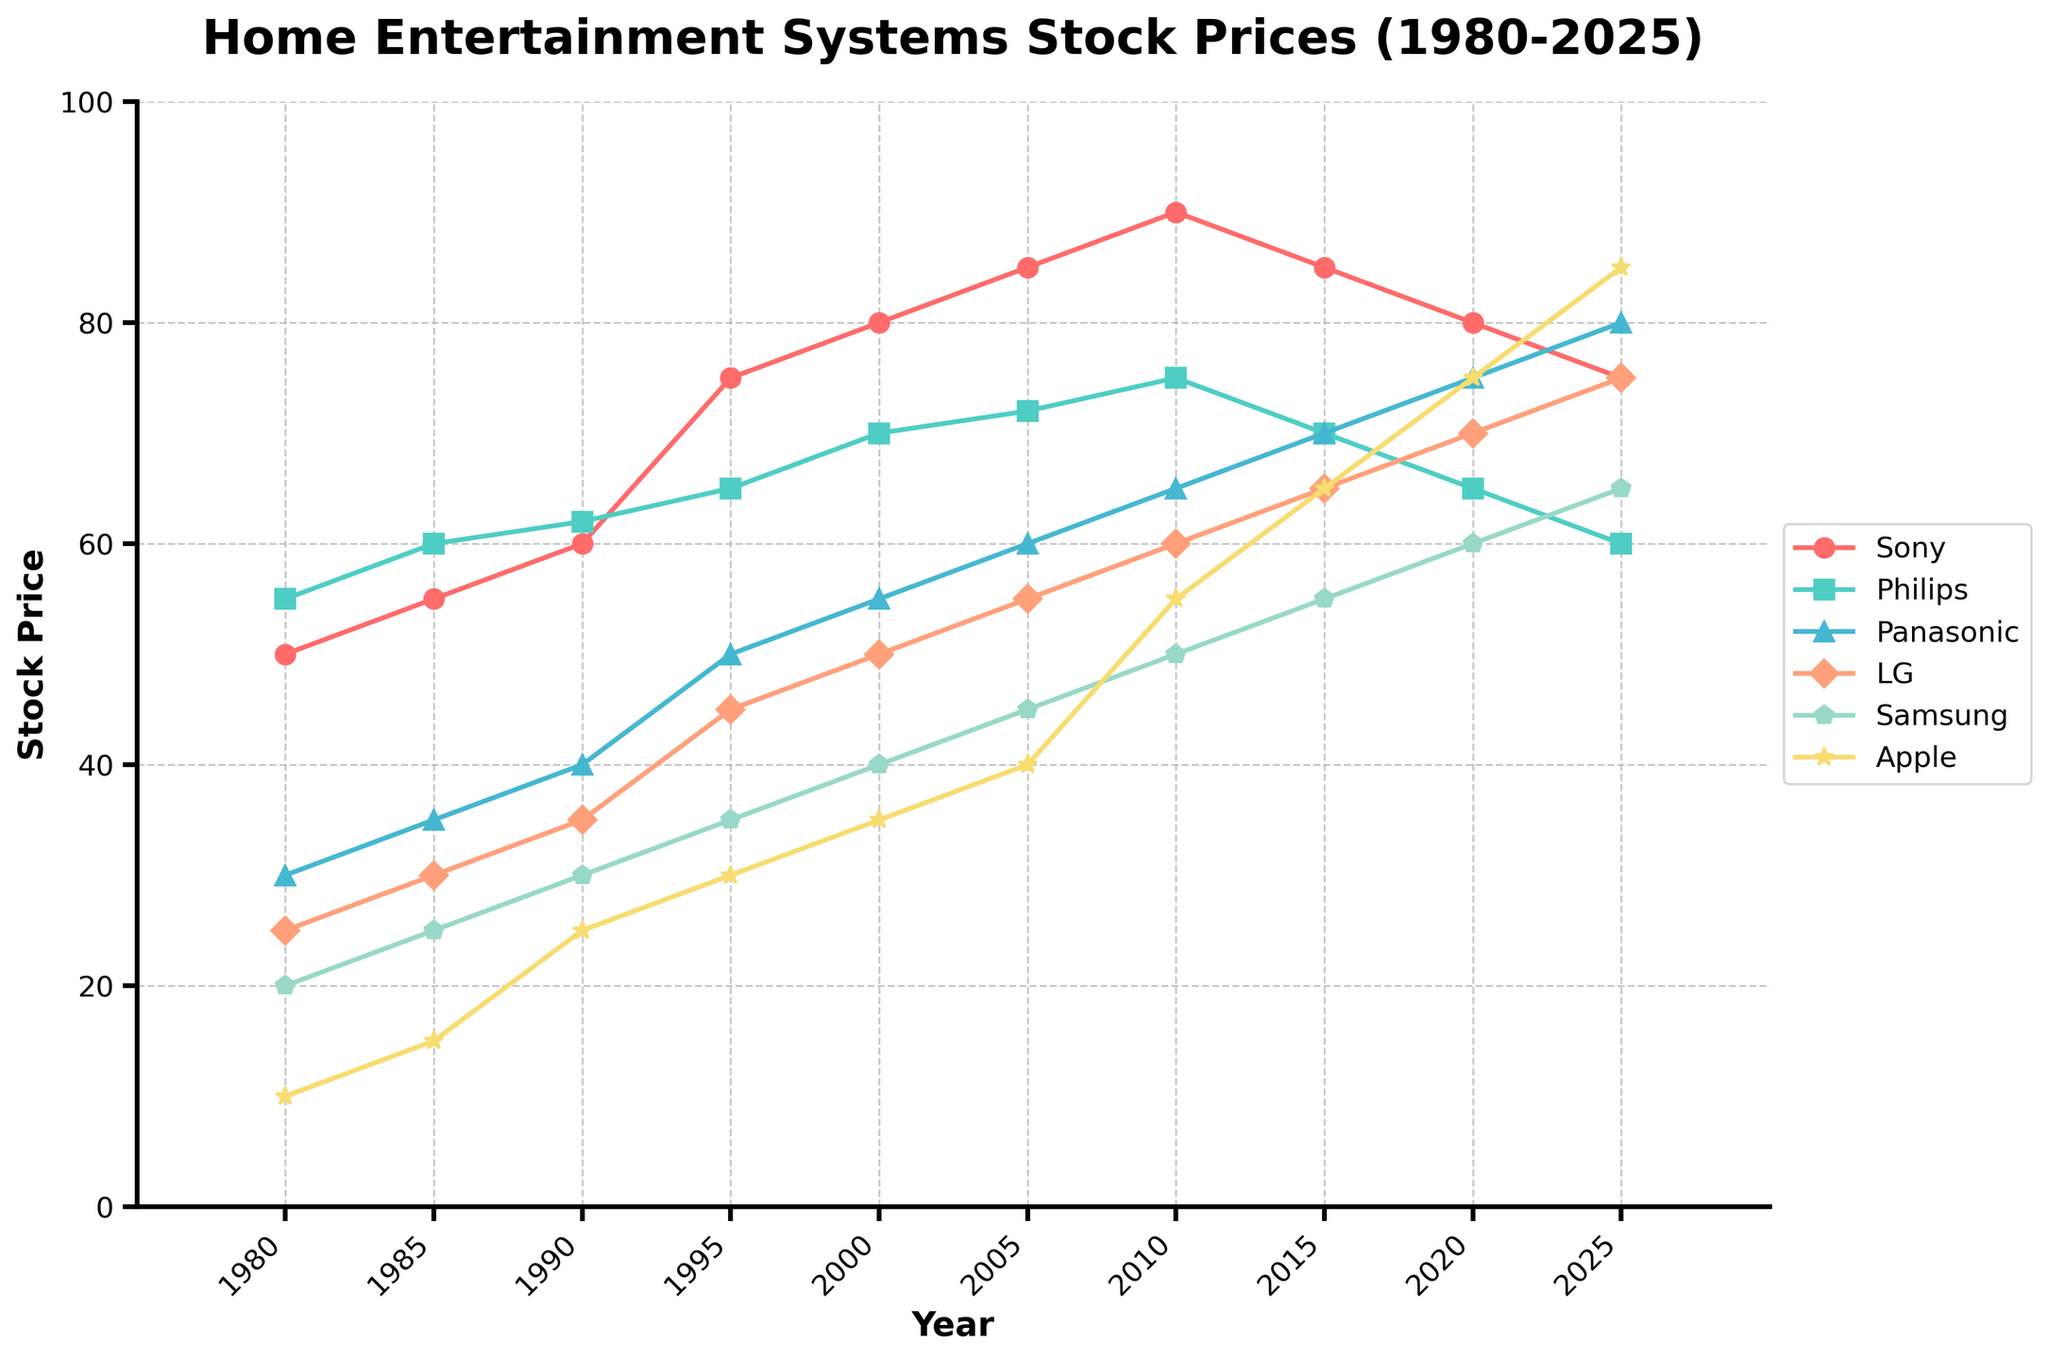What is the title of the plot? The title is displayed at the top of the plot. It is "Home Entertainment Systems Stock Prices (1980-2025)"
Answer: Home Entertainment Systems Stock Prices (1980-2025) Which company had the highest stock price in 2025? Find the 2025 data points and compare the values for each company. Apple has the highest value at 85.
Answer: Apple How many years are represented in the plot? Count the unique years on the x-axis. The years are from 1980 to 2025 with a total of 10 intervals.
Answer: 10 years What was the trend in Sony's stock price from 1980 to 2025? Track Sony's data points over the years from 1980 to 2025. Sony's stock price starts at 50 in 1980, gradually rises until 2010, and then declines until 2025.
Answer: Gradually increased, then declined What was the stock price difference between LG and Panasonic in 1995? Look at the values for LG and Panasonic in 1995: LG is 45 and Panasonic is 50. Subtract 45 from 50.
Answer: 5 Which company showed the most consistent increase in stock price over the entire period? Find the company with a consistent upward trend in stock prices without significant drops. Samsung's data points steadily increase from 20 in 1980 to 65 in 2025.
Answer: Samsung What are the two companies with the highest growth rate between 1980 and 2025? Compare the starting and ending stock prices of all companies. Apple increased from 10 to 85 (growth rate of 75). Panasonic increased from 30 to 80 (growth rate of 50).
Answer: Apple and Panasonic Between 2005 and 2025, which company had the largest decline in stock price? Look at the stock prices for each company in 2005 and 2025 and find the one with the largest negative difference. Sony's price went from 85 to 75 (a decline of 10).
Answer: Sony Did any company surpass Sony's stock price in 2020? Look at Sony’s value in 2020 (80) and check if any other company has a higher value. Panasonic, LG, and Apple have values of 75, 70, and 75, respectively, which are all lower.
Answer: No What's the average stock price of Philips over the given period? Sum up Philips' stock prices from 1980 to 2025 and divide by the number of years. (55 + 60 + 62 + 65 + 70 + 72 + 75 + 70 + 65 + 60) / 10 = 65.4
Answer: 65.4 